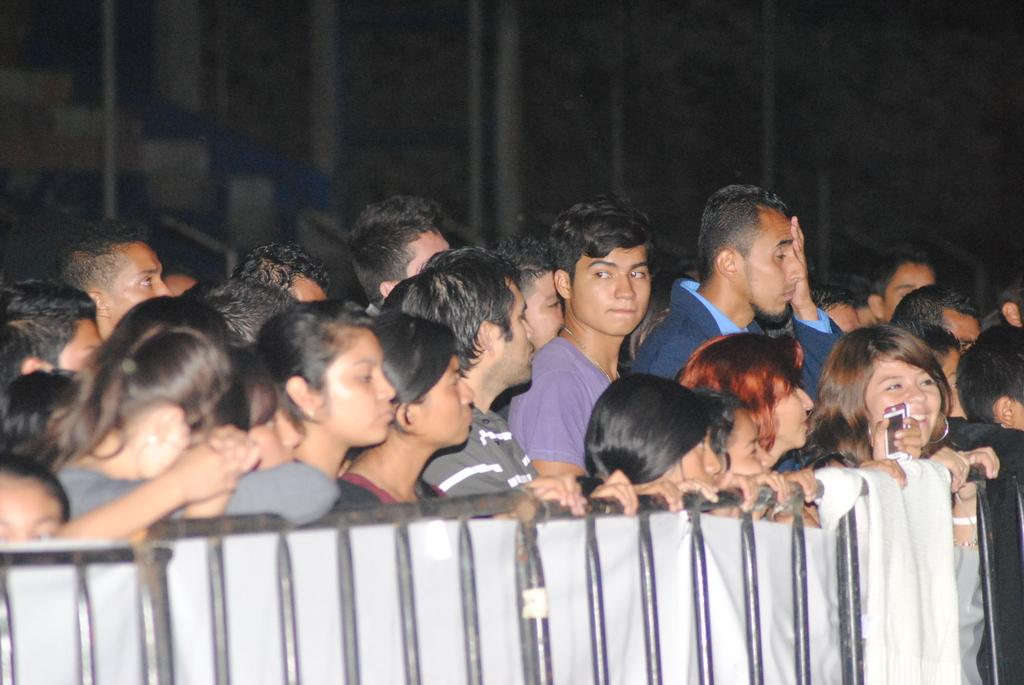What is the main subject of the image? The main subject of the image is a crowd. Can you describe any additional features in the image? Yes, there is a railing with cloth in front of the crowd. What type of feast is being prepared by the doctor in the school depicted in the image? There is no feast, doctor, or school present in the image; it only features a crowd and a railing with cloth. 